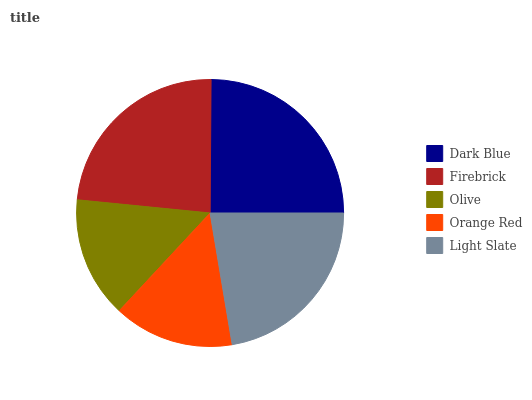Is Orange Red the minimum?
Answer yes or no. Yes. Is Dark Blue the maximum?
Answer yes or no. Yes. Is Firebrick the minimum?
Answer yes or no. No. Is Firebrick the maximum?
Answer yes or no. No. Is Dark Blue greater than Firebrick?
Answer yes or no. Yes. Is Firebrick less than Dark Blue?
Answer yes or no. Yes. Is Firebrick greater than Dark Blue?
Answer yes or no. No. Is Dark Blue less than Firebrick?
Answer yes or no. No. Is Light Slate the high median?
Answer yes or no. Yes. Is Light Slate the low median?
Answer yes or no. Yes. Is Dark Blue the high median?
Answer yes or no. No. Is Firebrick the low median?
Answer yes or no. No. 